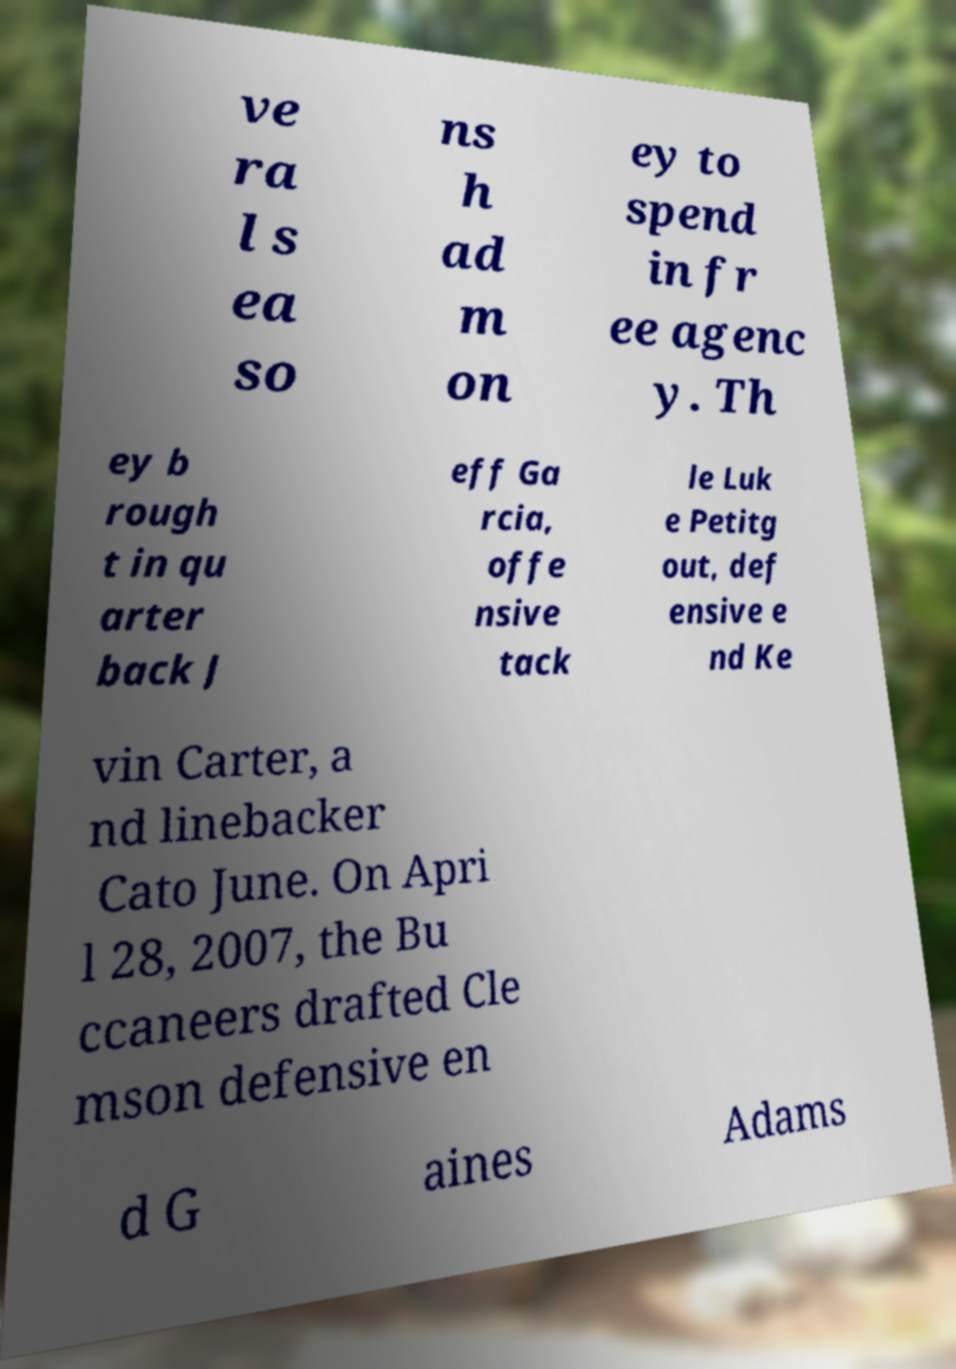What messages or text are displayed in this image? I need them in a readable, typed format. ve ra l s ea so ns h ad m on ey to spend in fr ee agenc y. Th ey b rough t in qu arter back J eff Ga rcia, offe nsive tack le Luk e Petitg out, def ensive e nd Ke vin Carter, a nd linebacker Cato June. On Apri l 28, 2007, the Bu ccaneers drafted Cle mson defensive en d G aines Adams 